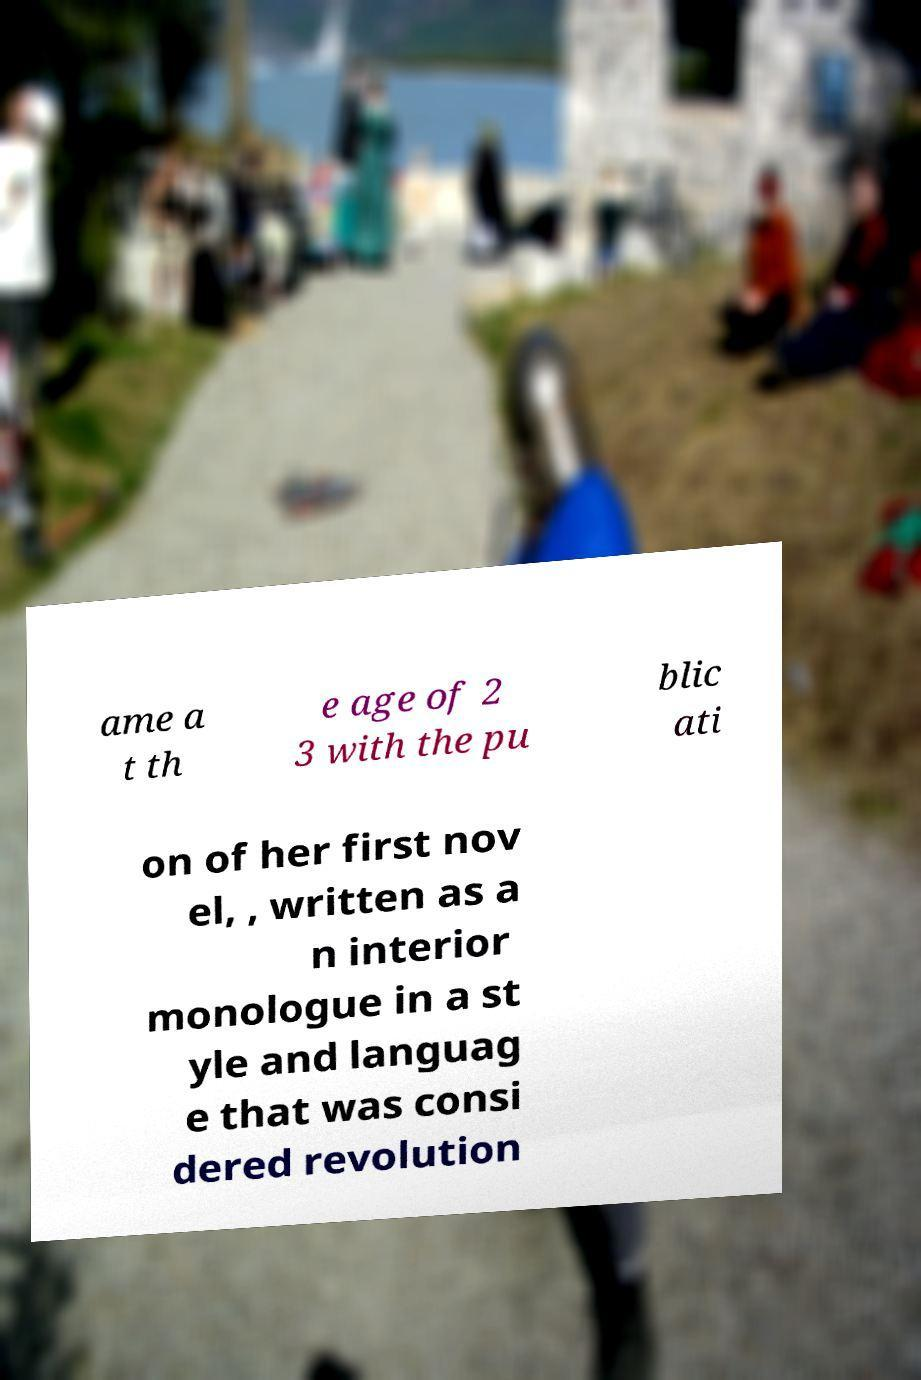For documentation purposes, I need the text within this image transcribed. Could you provide that? ame a t th e age of 2 3 with the pu blic ati on of her first nov el, , written as a n interior monologue in a st yle and languag e that was consi dered revolution 